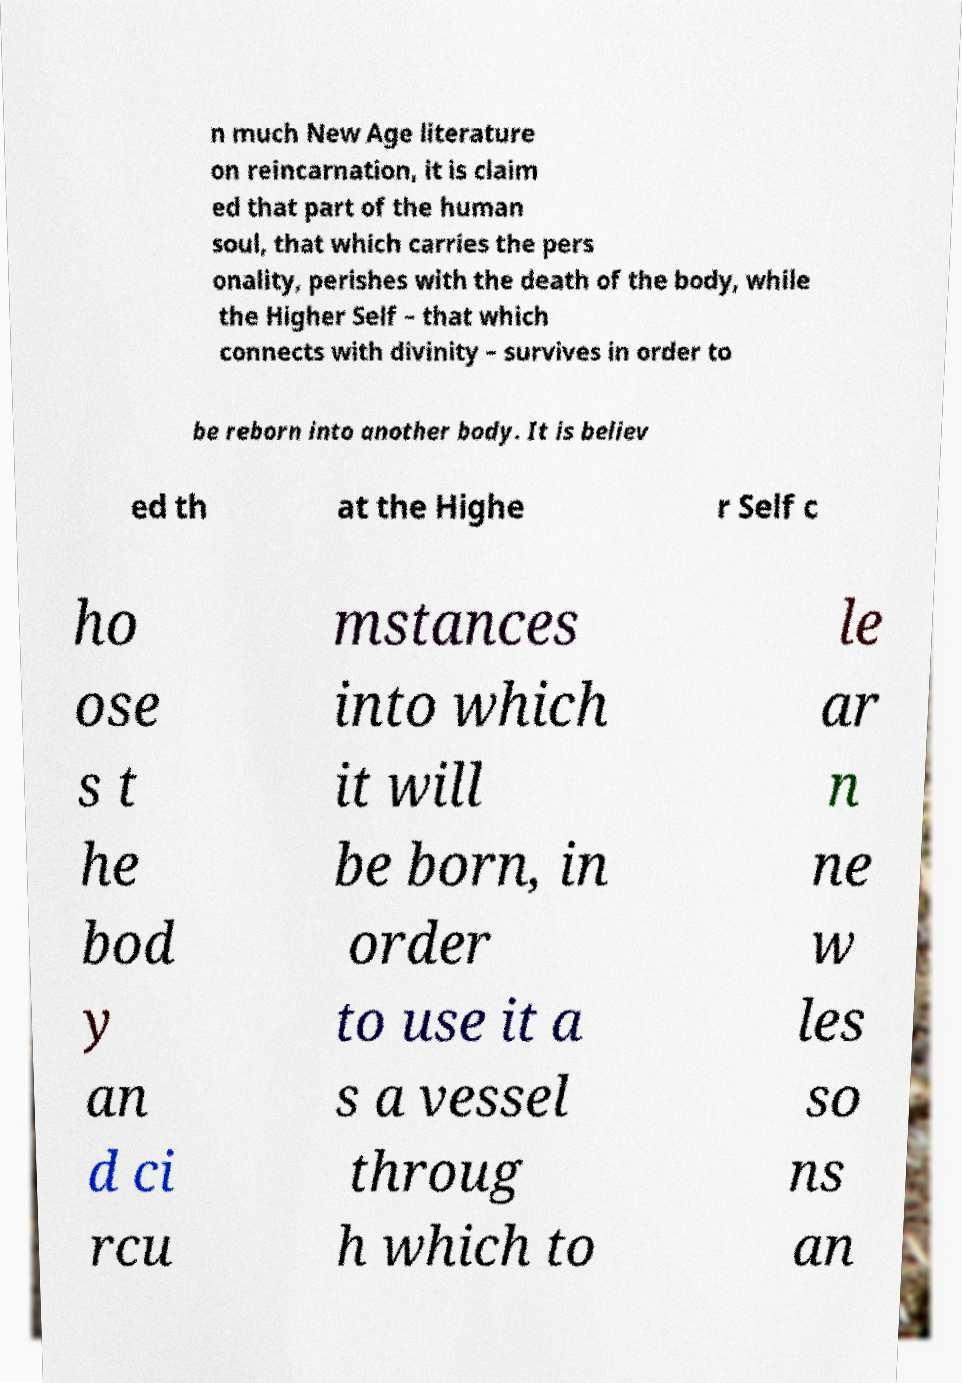Could you assist in decoding the text presented in this image and type it out clearly? n much New Age literature on reincarnation, it is claim ed that part of the human soul, that which carries the pers onality, perishes with the death of the body, while the Higher Self – that which connects with divinity – survives in order to be reborn into another body. It is believ ed th at the Highe r Self c ho ose s t he bod y an d ci rcu mstances into which it will be born, in order to use it a s a vessel throug h which to le ar n ne w les so ns an 